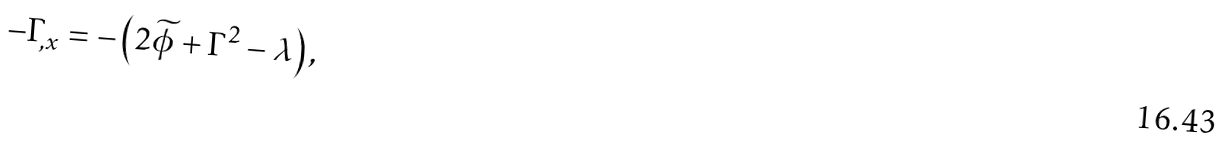Convert formula to latex. <formula><loc_0><loc_0><loc_500><loc_500>- \Gamma _ { , x } = - \left ( 2 \widetilde { \phi } + \Gamma ^ { 2 } - \lambda \right ) ,</formula> 